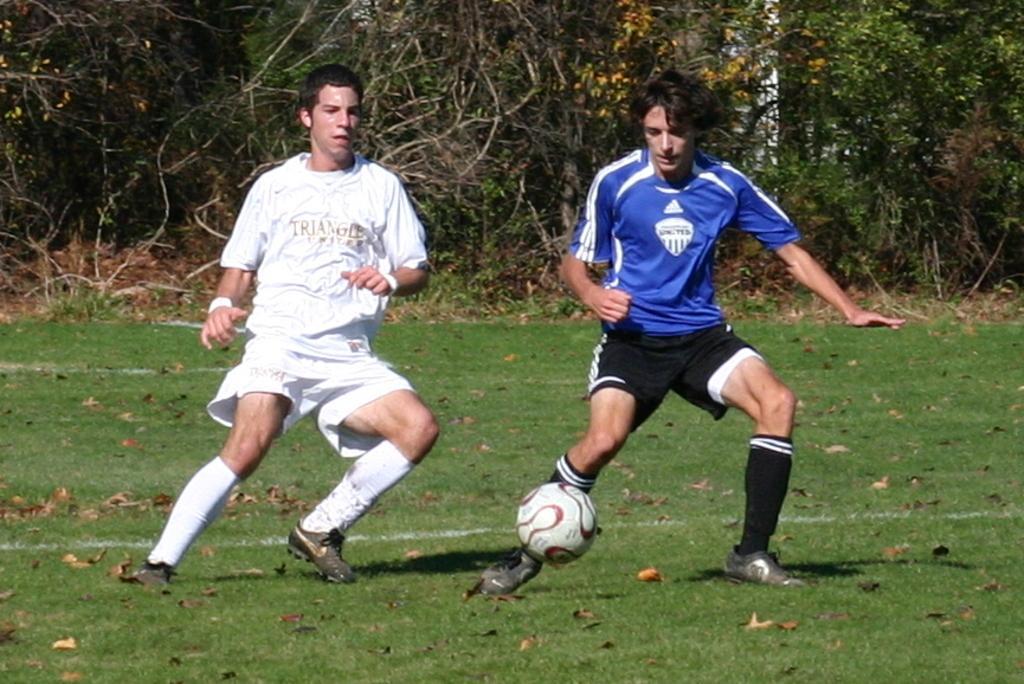Could you give a brief overview of what you see in this image? In this picture there are two boys in the center of the image on the grassland, they are playing football and there is a ball at at the bottom side of the image and there are trees in the background area of the image. 